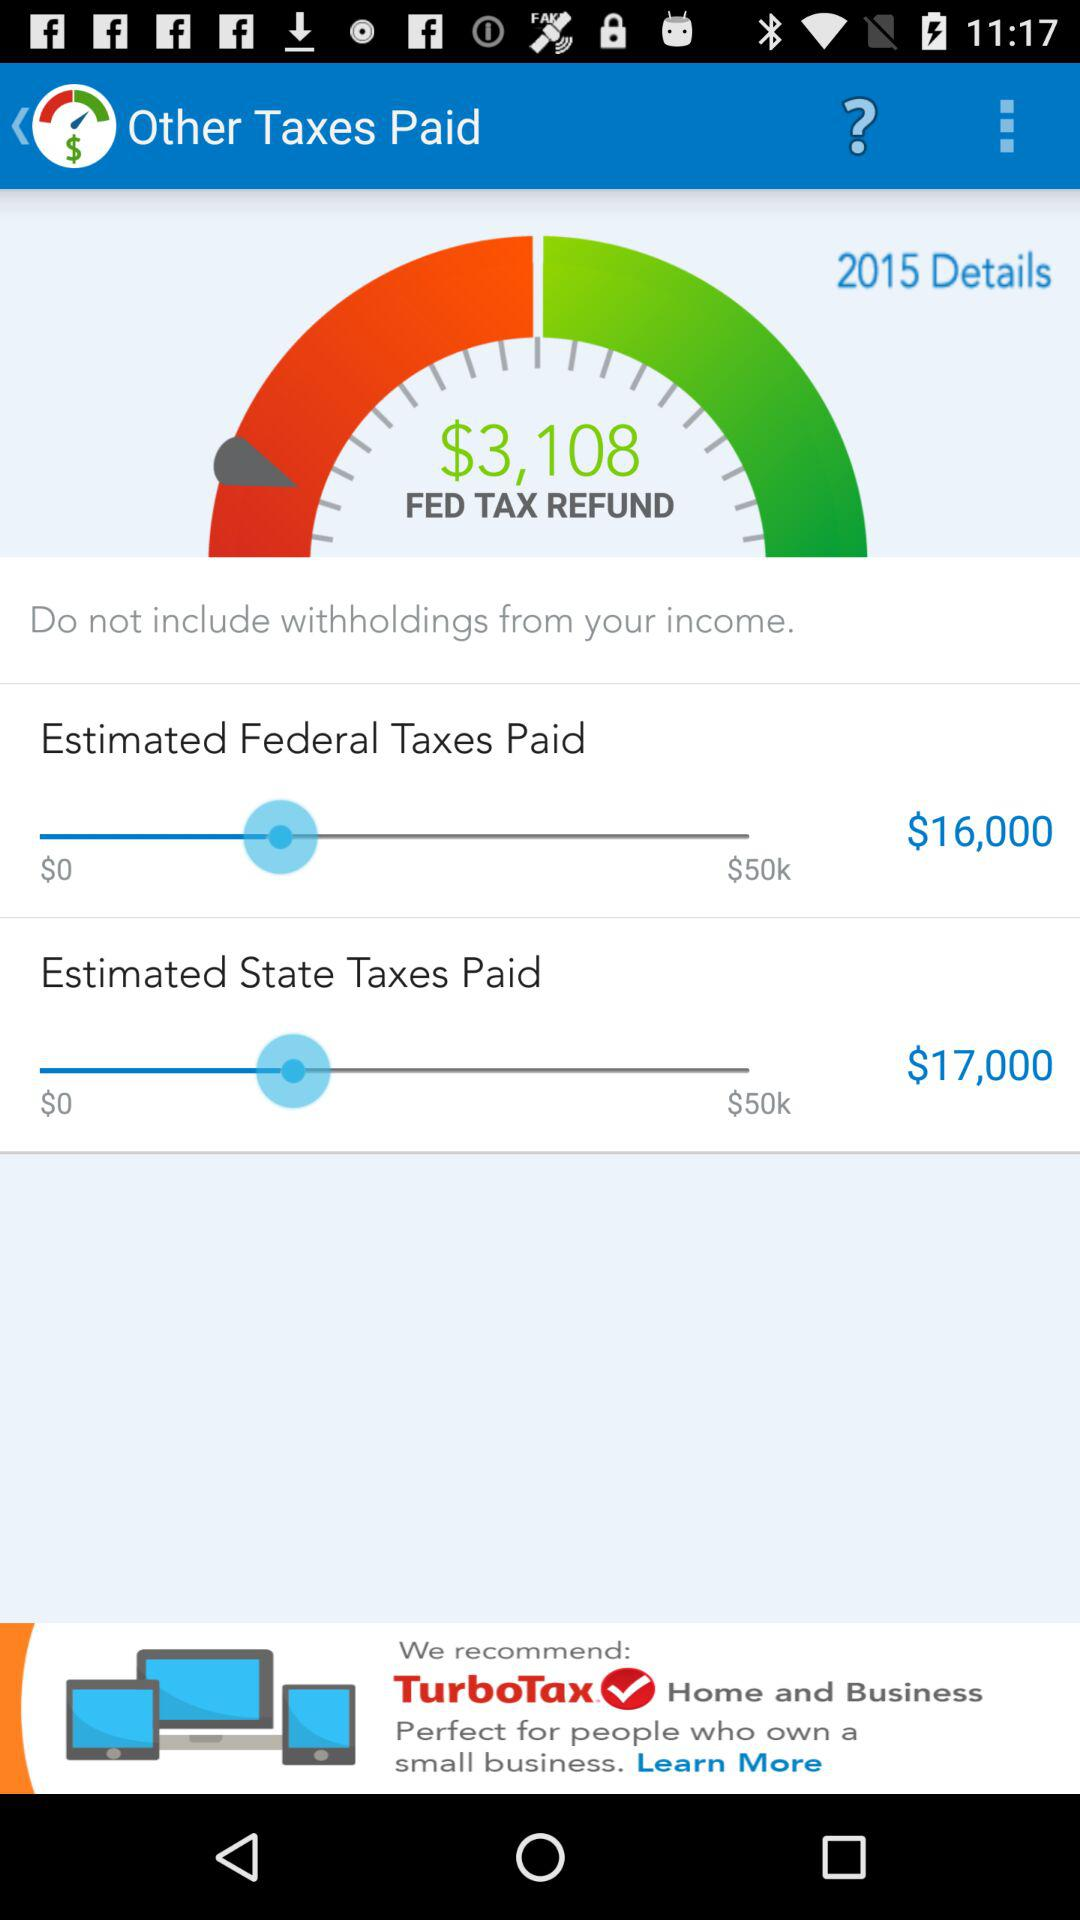What's the "FED TAX REFUND" amount? The "FED TAX REFUND" amount is $3,108. 